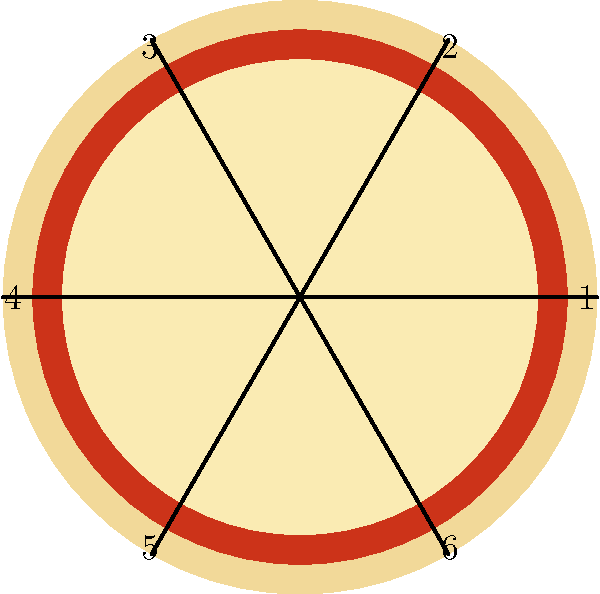A popular Chicago-style deep-dish pizza is cut into 6 equal slices, as shown in the diagram. Each slice is numbered from 1 to 6. If we consider the rotational symmetry of this pizza, which can be described by the cyclic group $C_6$, what is the result of applying the group operation $r^4 \circ r^5$ to slice number 1, where $r$ represents a clockwise rotation by 60°? Let's approach this step-by-step:

1) In the cyclic group $C_6$, $r$ represents a clockwise rotation by 60°.

2) $r^4$ means applying this rotation 4 times, which is equivalent to a 240° clockwise rotation.

3) $r^5$ means applying the rotation 5 times, equivalent to a 300° clockwise rotation.

4) The operation $r^4 \circ r^5$ means we first apply $r^5$, then $r^4$.

5) $r^5$ rotates slice 1 by 300° clockwise, which brings it to the position of slice 2.

6) From this new position, we then apply $r^4$ (240° clockwise), which moves it 4 more positions.

7) In $C_6$, we can simplify this operation:
   $r^4 \circ r^5 = r^9 = r^3$ (since $r^6 = e$, the identity element)

8) $r^3$ is equivalent to a 180° rotation.

9) A 180° rotation from the original position of slice 1 lands on slice 4.

Therefore, applying $r^4 \circ r^5$ to slice 1 results in slice 4.
Answer: 4 